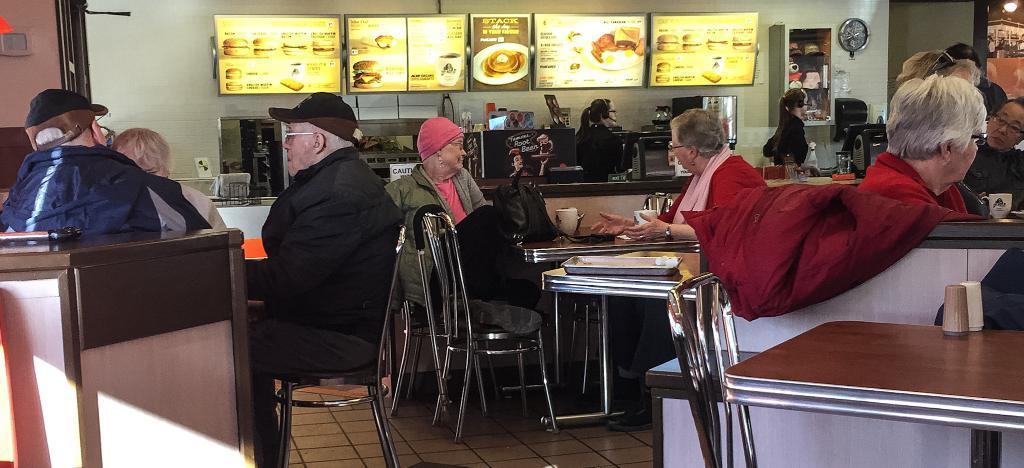Can you describe this image briefly? The picture is clicked inside a restaurant where there are people sitting on the tables and in the background few monitors are present which displays liquid menu. 